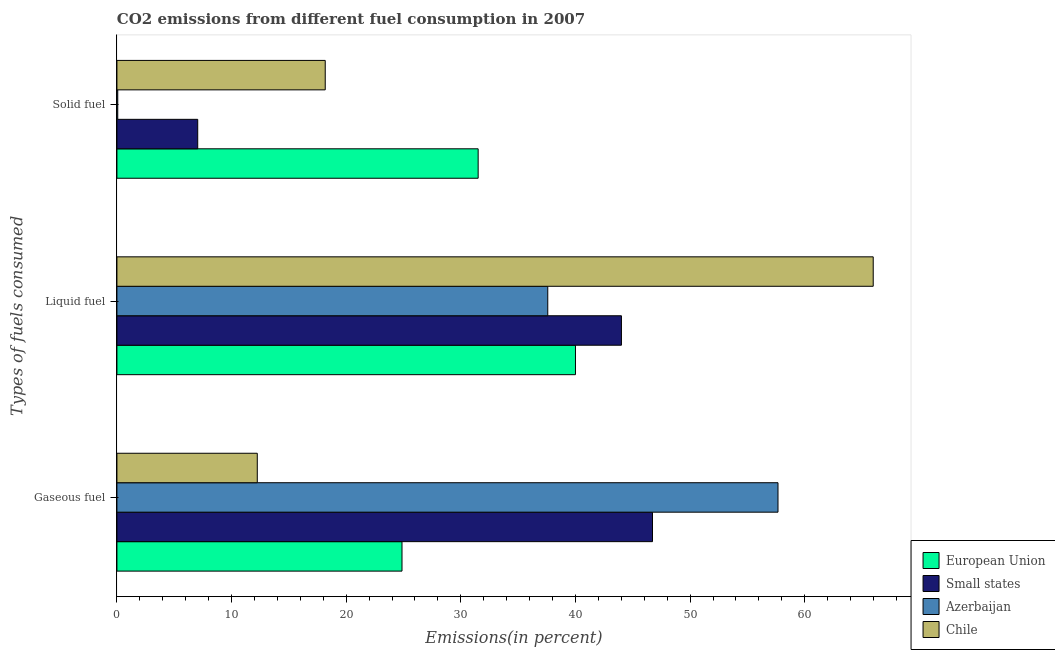How many different coloured bars are there?
Offer a terse response. 4. How many bars are there on the 2nd tick from the top?
Offer a terse response. 4. What is the label of the 1st group of bars from the top?
Make the answer very short. Solid fuel. What is the percentage of solid fuel emission in Azerbaijan?
Provide a succinct answer. 0.07. Across all countries, what is the maximum percentage of gaseous fuel emission?
Give a very brief answer. 57.67. Across all countries, what is the minimum percentage of solid fuel emission?
Make the answer very short. 0.07. In which country was the percentage of solid fuel emission minimum?
Give a very brief answer. Azerbaijan. What is the total percentage of solid fuel emission in the graph?
Make the answer very short. 56.8. What is the difference between the percentage of gaseous fuel emission in Chile and that in Small states?
Provide a succinct answer. -34.48. What is the difference between the percentage of solid fuel emission in European Union and the percentage of liquid fuel emission in Azerbaijan?
Keep it short and to the point. -6.07. What is the average percentage of solid fuel emission per country?
Your response must be concise. 14.2. What is the difference between the percentage of gaseous fuel emission and percentage of solid fuel emission in Chile?
Provide a short and direct response. -5.93. What is the ratio of the percentage of liquid fuel emission in Azerbaijan to that in Small states?
Give a very brief answer. 0.85. Is the percentage of gaseous fuel emission in European Union less than that in Azerbaijan?
Your response must be concise. Yes. Is the difference between the percentage of liquid fuel emission in Azerbaijan and Chile greater than the difference between the percentage of gaseous fuel emission in Azerbaijan and Chile?
Ensure brevity in your answer.  No. What is the difference between the highest and the second highest percentage of gaseous fuel emission?
Make the answer very short. 10.95. What is the difference between the highest and the lowest percentage of liquid fuel emission?
Your response must be concise. 28.39. What does the 2nd bar from the top in Liquid fuel represents?
Keep it short and to the point. Azerbaijan. What does the 3rd bar from the bottom in Liquid fuel represents?
Your answer should be compact. Azerbaijan. Does the graph contain any zero values?
Your response must be concise. No. Does the graph contain grids?
Give a very brief answer. No. How are the legend labels stacked?
Provide a short and direct response. Vertical. What is the title of the graph?
Your answer should be compact. CO2 emissions from different fuel consumption in 2007. What is the label or title of the X-axis?
Your answer should be compact. Emissions(in percent). What is the label or title of the Y-axis?
Make the answer very short. Types of fuels consumed. What is the Emissions(in percent) in European Union in Gaseous fuel?
Make the answer very short. 24.87. What is the Emissions(in percent) of Small states in Gaseous fuel?
Make the answer very short. 46.72. What is the Emissions(in percent) in Azerbaijan in Gaseous fuel?
Your response must be concise. 57.67. What is the Emissions(in percent) in Chile in Gaseous fuel?
Ensure brevity in your answer.  12.24. What is the Emissions(in percent) of European Union in Liquid fuel?
Provide a short and direct response. 40. What is the Emissions(in percent) in Small states in Liquid fuel?
Provide a succinct answer. 44.01. What is the Emissions(in percent) of Azerbaijan in Liquid fuel?
Offer a terse response. 37.58. What is the Emissions(in percent) of Chile in Liquid fuel?
Provide a short and direct response. 65.98. What is the Emissions(in percent) of European Union in Solid fuel?
Offer a very short reply. 31.51. What is the Emissions(in percent) in Small states in Solid fuel?
Keep it short and to the point. 7.05. What is the Emissions(in percent) of Azerbaijan in Solid fuel?
Provide a succinct answer. 0.07. What is the Emissions(in percent) of Chile in Solid fuel?
Offer a terse response. 18.17. Across all Types of fuels consumed, what is the maximum Emissions(in percent) in European Union?
Offer a very short reply. 40. Across all Types of fuels consumed, what is the maximum Emissions(in percent) of Small states?
Your answer should be compact. 46.72. Across all Types of fuels consumed, what is the maximum Emissions(in percent) in Azerbaijan?
Provide a short and direct response. 57.67. Across all Types of fuels consumed, what is the maximum Emissions(in percent) of Chile?
Your answer should be very brief. 65.98. Across all Types of fuels consumed, what is the minimum Emissions(in percent) in European Union?
Make the answer very short. 24.87. Across all Types of fuels consumed, what is the minimum Emissions(in percent) of Small states?
Make the answer very short. 7.05. Across all Types of fuels consumed, what is the minimum Emissions(in percent) of Azerbaijan?
Your response must be concise. 0.07. Across all Types of fuels consumed, what is the minimum Emissions(in percent) in Chile?
Your response must be concise. 12.24. What is the total Emissions(in percent) in European Union in the graph?
Your answer should be compact. 96.38. What is the total Emissions(in percent) of Small states in the graph?
Keep it short and to the point. 97.78. What is the total Emissions(in percent) in Azerbaijan in the graph?
Make the answer very short. 95.32. What is the total Emissions(in percent) of Chile in the graph?
Provide a succinct answer. 96.39. What is the difference between the Emissions(in percent) in European Union in Gaseous fuel and that in Liquid fuel?
Give a very brief answer. -15.13. What is the difference between the Emissions(in percent) of Small states in Gaseous fuel and that in Liquid fuel?
Ensure brevity in your answer.  2.71. What is the difference between the Emissions(in percent) in Azerbaijan in Gaseous fuel and that in Liquid fuel?
Your answer should be very brief. 20.08. What is the difference between the Emissions(in percent) in Chile in Gaseous fuel and that in Liquid fuel?
Offer a terse response. -53.73. What is the difference between the Emissions(in percent) of European Union in Gaseous fuel and that in Solid fuel?
Keep it short and to the point. -6.64. What is the difference between the Emissions(in percent) in Small states in Gaseous fuel and that in Solid fuel?
Provide a succinct answer. 39.67. What is the difference between the Emissions(in percent) of Azerbaijan in Gaseous fuel and that in Solid fuel?
Your response must be concise. 57.6. What is the difference between the Emissions(in percent) of Chile in Gaseous fuel and that in Solid fuel?
Ensure brevity in your answer.  -5.93. What is the difference between the Emissions(in percent) of European Union in Liquid fuel and that in Solid fuel?
Keep it short and to the point. 8.49. What is the difference between the Emissions(in percent) in Small states in Liquid fuel and that in Solid fuel?
Ensure brevity in your answer.  36.96. What is the difference between the Emissions(in percent) of Azerbaijan in Liquid fuel and that in Solid fuel?
Ensure brevity in your answer.  37.51. What is the difference between the Emissions(in percent) in Chile in Liquid fuel and that in Solid fuel?
Offer a very short reply. 47.8. What is the difference between the Emissions(in percent) of European Union in Gaseous fuel and the Emissions(in percent) of Small states in Liquid fuel?
Ensure brevity in your answer.  -19.14. What is the difference between the Emissions(in percent) of European Union in Gaseous fuel and the Emissions(in percent) of Azerbaijan in Liquid fuel?
Make the answer very short. -12.72. What is the difference between the Emissions(in percent) of European Union in Gaseous fuel and the Emissions(in percent) of Chile in Liquid fuel?
Your answer should be compact. -41.11. What is the difference between the Emissions(in percent) in Small states in Gaseous fuel and the Emissions(in percent) in Azerbaijan in Liquid fuel?
Give a very brief answer. 9.14. What is the difference between the Emissions(in percent) in Small states in Gaseous fuel and the Emissions(in percent) in Chile in Liquid fuel?
Provide a succinct answer. -19.25. What is the difference between the Emissions(in percent) in Azerbaijan in Gaseous fuel and the Emissions(in percent) in Chile in Liquid fuel?
Offer a terse response. -8.31. What is the difference between the Emissions(in percent) in European Union in Gaseous fuel and the Emissions(in percent) in Small states in Solid fuel?
Provide a short and direct response. 17.82. What is the difference between the Emissions(in percent) in European Union in Gaseous fuel and the Emissions(in percent) in Azerbaijan in Solid fuel?
Make the answer very short. 24.8. What is the difference between the Emissions(in percent) in European Union in Gaseous fuel and the Emissions(in percent) in Chile in Solid fuel?
Offer a very short reply. 6.7. What is the difference between the Emissions(in percent) in Small states in Gaseous fuel and the Emissions(in percent) in Azerbaijan in Solid fuel?
Your response must be concise. 46.65. What is the difference between the Emissions(in percent) of Small states in Gaseous fuel and the Emissions(in percent) of Chile in Solid fuel?
Offer a terse response. 28.55. What is the difference between the Emissions(in percent) of Azerbaijan in Gaseous fuel and the Emissions(in percent) of Chile in Solid fuel?
Offer a very short reply. 39.5. What is the difference between the Emissions(in percent) of European Union in Liquid fuel and the Emissions(in percent) of Small states in Solid fuel?
Offer a very short reply. 32.95. What is the difference between the Emissions(in percent) of European Union in Liquid fuel and the Emissions(in percent) of Azerbaijan in Solid fuel?
Your answer should be compact. 39.93. What is the difference between the Emissions(in percent) in European Union in Liquid fuel and the Emissions(in percent) in Chile in Solid fuel?
Your response must be concise. 21.83. What is the difference between the Emissions(in percent) in Small states in Liquid fuel and the Emissions(in percent) in Azerbaijan in Solid fuel?
Offer a very short reply. 43.94. What is the difference between the Emissions(in percent) in Small states in Liquid fuel and the Emissions(in percent) in Chile in Solid fuel?
Make the answer very short. 25.84. What is the difference between the Emissions(in percent) in Azerbaijan in Liquid fuel and the Emissions(in percent) in Chile in Solid fuel?
Offer a very short reply. 19.41. What is the average Emissions(in percent) of European Union per Types of fuels consumed?
Provide a short and direct response. 32.13. What is the average Emissions(in percent) of Small states per Types of fuels consumed?
Keep it short and to the point. 32.59. What is the average Emissions(in percent) of Azerbaijan per Types of fuels consumed?
Your answer should be compact. 31.77. What is the average Emissions(in percent) of Chile per Types of fuels consumed?
Provide a short and direct response. 32.13. What is the difference between the Emissions(in percent) in European Union and Emissions(in percent) in Small states in Gaseous fuel?
Your response must be concise. -21.85. What is the difference between the Emissions(in percent) in European Union and Emissions(in percent) in Azerbaijan in Gaseous fuel?
Offer a terse response. -32.8. What is the difference between the Emissions(in percent) of European Union and Emissions(in percent) of Chile in Gaseous fuel?
Provide a short and direct response. 12.62. What is the difference between the Emissions(in percent) in Small states and Emissions(in percent) in Azerbaijan in Gaseous fuel?
Provide a succinct answer. -10.95. What is the difference between the Emissions(in percent) of Small states and Emissions(in percent) of Chile in Gaseous fuel?
Your answer should be very brief. 34.48. What is the difference between the Emissions(in percent) in Azerbaijan and Emissions(in percent) in Chile in Gaseous fuel?
Offer a very short reply. 45.42. What is the difference between the Emissions(in percent) in European Union and Emissions(in percent) in Small states in Liquid fuel?
Provide a short and direct response. -4.01. What is the difference between the Emissions(in percent) of European Union and Emissions(in percent) of Azerbaijan in Liquid fuel?
Make the answer very short. 2.42. What is the difference between the Emissions(in percent) in European Union and Emissions(in percent) in Chile in Liquid fuel?
Give a very brief answer. -25.98. What is the difference between the Emissions(in percent) of Small states and Emissions(in percent) of Azerbaijan in Liquid fuel?
Ensure brevity in your answer.  6.43. What is the difference between the Emissions(in percent) in Small states and Emissions(in percent) in Chile in Liquid fuel?
Provide a succinct answer. -21.96. What is the difference between the Emissions(in percent) of Azerbaijan and Emissions(in percent) of Chile in Liquid fuel?
Give a very brief answer. -28.39. What is the difference between the Emissions(in percent) in European Union and Emissions(in percent) in Small states in Solid fuel?
Your response must be concise. 24.46. What is the difference between the Emissions(in percent) in European Union and Emissions(in percent) in Azerbaijan in Solid fuel?
Make the answer very short. 31.44. What is the difference between the Emissions(in percent) in European Union and Emissions(in percent) in Chile in Solid fuel?
Offer a terse response. 13.34. What is the difference between the Emissions(in percent) of Small states and Emissions(in percent) of Azerbaijan in Solid fuel?
Your answer should be very brief. 6.98. What is the difference between the Emissions(in percent) of Small states and Emissions(in percent) of Chile in Solid fuel?
Offer a very short reply. -11.12. What is the difference between the Emissions(in percent) in Azerbaijan and Emissions(in percent) in Chile in Solid fuel?
Provide a succinct answer. -18.1. What is the ratio of the Emissions(in percent) of European Union in Gaseous fuel to that in Liquid fuel?
Give a very brief answer. 0.62. What is the ratio of the Emissions(in percent) of Small states in Gaseous fuel to that in Liquid fuel?
Your answer should be compact. 1.06. What is the ratio of the Emissions(in percent) of Azerbaijan in Gaseous fuel to that in Liquid fuel?
Your response must be concise. 1.53. What is the ratio of the Emissions(in percent) in Chile in Gaseous fuel to that in Liquid fuel?
Keep it short and to the point. 0.19. What is the ratio of the Emissions(in percent) of European Union in Gaseous fuel to that in Solid fuel?
Make the answer very short. 0.79. What is the ratio of the Emissions(in percent) of Small states in Gaseous fuel to that in Solid fuel?
Offer a very short reply. 6.63. What is the ratio of the Emissions(in percent) of Azerbaijan in Gaseous fuel to that in Solid fuel?
Make the answer very short. 799.67. What is the ratio of the Emissions(in percent) of Chile in Gaseous fuel to that in Solid fuel?
Your response must be concise. 0.67. What is the ratio of the Emissions(in percent) of European Union in Liquid fuel to that in Solid fuel?
Your answer should be very brief. 1.27. What is the ratio of the Emissions(in percent) in Small states in Liquid fuel to that in Solid fuel?
Provide a succinct answer. 6.24. What is the ratio of the Emissions(in percent) of Azerbaijan in Liquid fuel to that in Solid fuel?
Your answer should be very brief. 521.17. What is the ratio of the Emissions(in percent) in Chile in Liquid fuel to that in Solid fuel?
Provide a short and direct response. 3.63. What is the difference between the highest and the second highest Emissions(in percent) in European Union?
Make the answer very short. 8.49. What is the difference between the highest and the second highest Emissions(in percent) in Small states?
Your response must be concise. 2.71. What is the difference between the highest and the second highest Emissions(in percent) of Azerbaijan?
Provide a short and direct response. 20.08. What is the difference between the highest and the second highest Emissions(in percent) of Chile?
Offer a very short reply. 47.8. What is the difference between the highest and the lowest Emissions(in percent) of European Union?
Offer a terse response. 15.13. What is the difference between the highest and the lowest Emissions(in percent) of Small states?
Give a very brief answer. 39.67. What is the difference between the highest and the lowest Emissions(in percent) of Azerbaijan?
Your response must be concise. 57.6. What is the difference between the highest and the lowest Emissions(in percent) in Chile?
Make the answer very short. 53.73. 